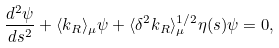<formula> <loc_0><loc_0><loc_500><loc_500>\frac { d ^ { 2 } \psi } { d s ^ { 2 } } + \langle k _ { R } \rangle _ { \mu } \psi + \langle \delta ^ { 2 } k _ { R } \rangle _ { \mu } ^ { 1 / 2 } \eta ( s ) \psi = 0 ,</formula> 